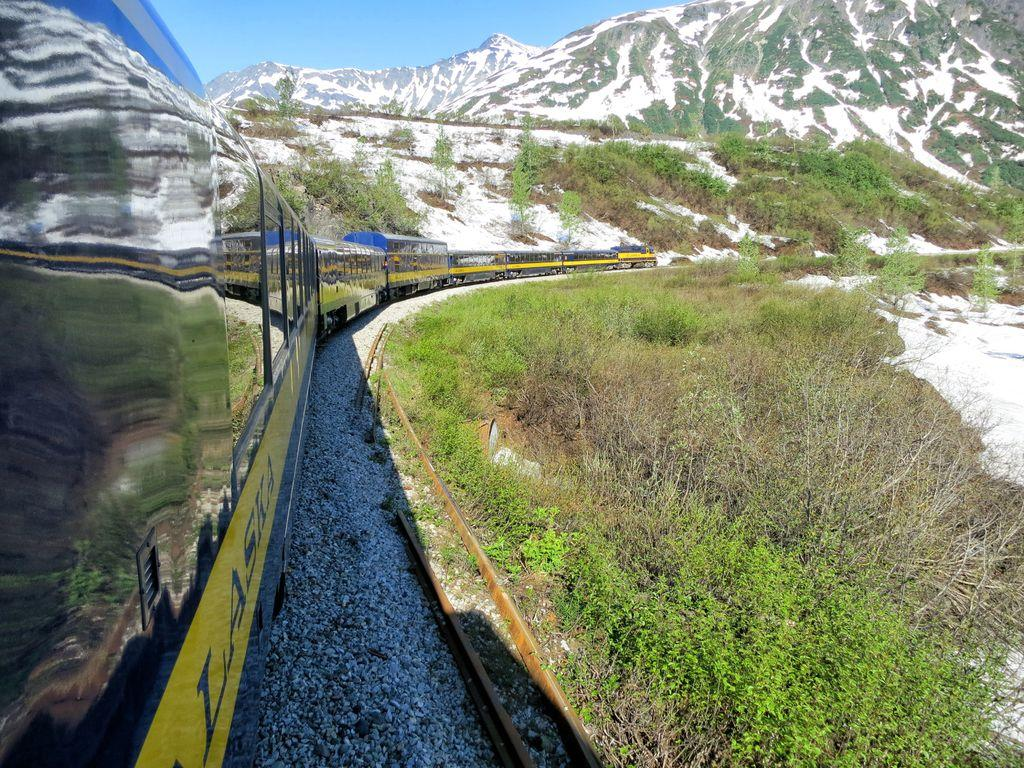What is the main subject of the image? The main subject of the image is a train. What is the train situated on? The train is situated on a railway track. What type of terrain is visible in the image? There are stones, trees, grass, and snow visible in the image. What can be seen in the background of the image? There are mountains and snow in the background of the image. Can you see a rose growing near the train in the image? There is no rose visible in the image. Is there a lake present in the image? There is no lake present in the image. 